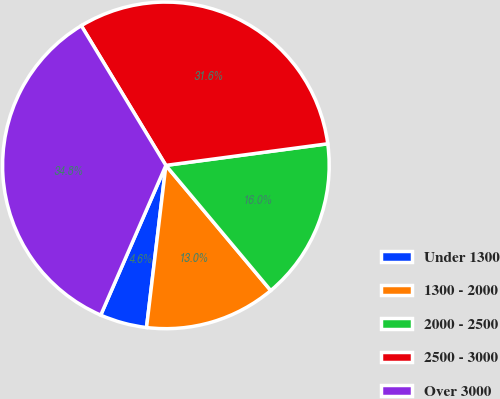Convert chart to OTSL. <chart><loc_0><loc_0><loc_500><loc_500><pie_chart><fcel>Under 1300<fcel>1300 - 2000<fcel>2000 - 2500<fcel>2500 - 3000<fcel>Over 3000<nl><fcel>4.64%<fcel>12.99%<fcel>16.01%<fcel>31.55%<fcel>34.8%<nl></chart> 